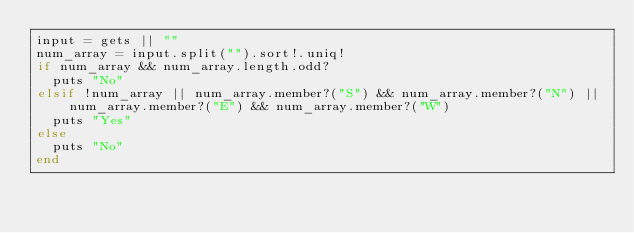Convert code to text. <code><loc_0><loc_0><loc_500><loc_500><_Ruby_>input = gets || ""
num_array = input.split("").sort!.uniq!
if num_array && num_array.length.odd?
  puts "No"
elsif !num_array || num_array.member?("S") && num_array.member?("N") || num_array.member?("E") && num_array.member?("W")
  puts "Yes"
else
  puts "No"
end</code> 